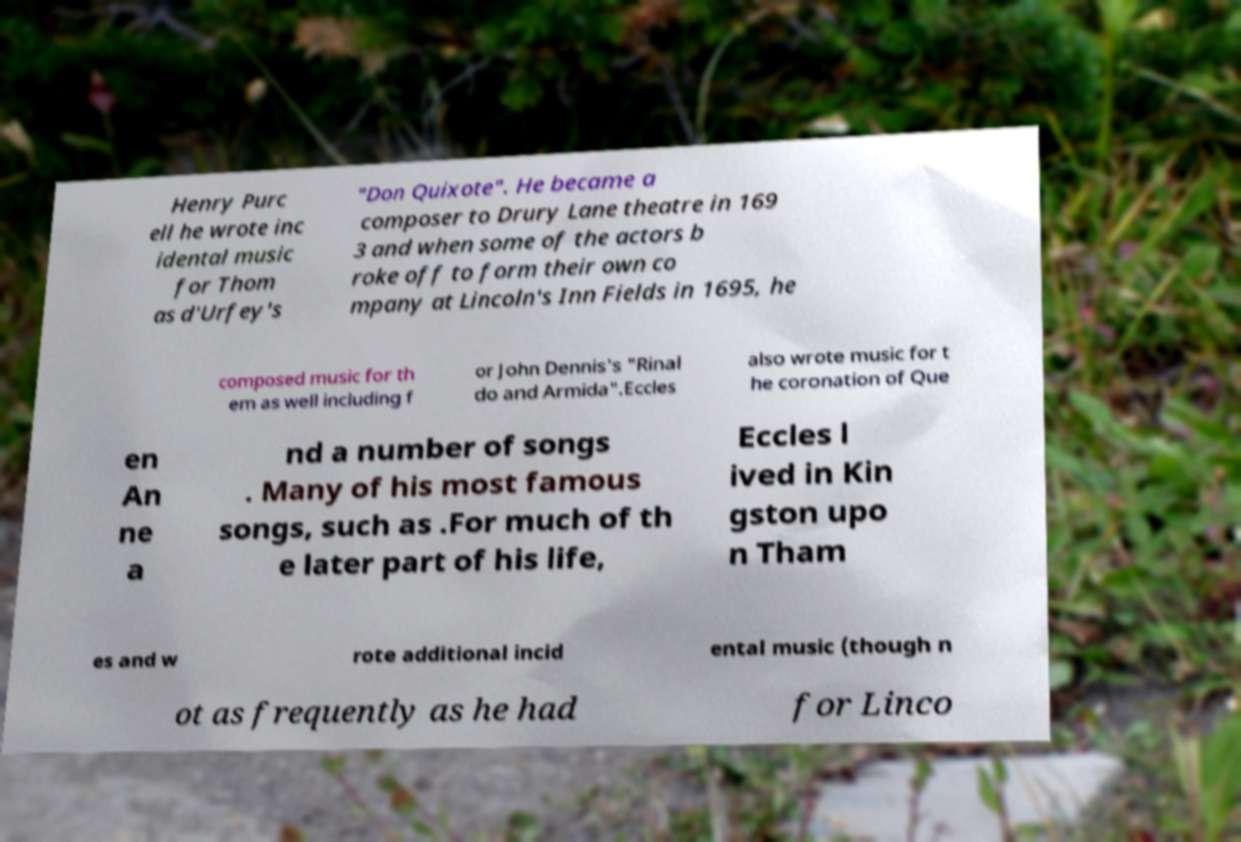Please read and relay the text visible in this image. What does it say? Henry Purc ell he wrote inc idental music for Thom as d'Urfey's "Don Quixote". He became a composer to Drury Lane theatre in 169 3 and when some of the actors b roke off to form their own co mpany at Lincoln's Inn Fields in 1695, he composed music for th em as well including f or John Dennis's "Rinal do and Armida".Eccles also wrote music for t he coronation of Que en An ne a nd a number of songs . Many of his most famous songs, such as .For much of th e later part of his life, Eccles l ived in Kin gston upo n Tham es and w rote additional incid ental music (though n ot as frequently as he had for Linco 